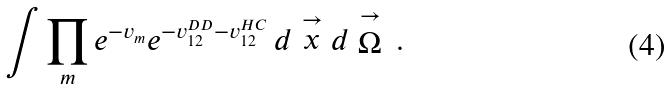<formula> <loc_0><loc_0><loc_500><loc_500>\int \prod _ { m } e ^ { - v _ { m } } e ^ { - v ^ { D D } _ { 1 2 } - v ^ { H C } _ { 1 2 } } \, d \stackrel { \rightarrow } { x } d \stackrel { \rightarrow } { \Omega } \, .</formula> 